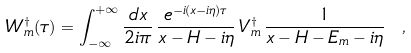Convert formula to latex. <formula><loc_0><loc_0><loc_500><loc_500>W _ { m } ^ { \dag } ( \tau ) = \int _ { - \infty } ^ { + \infty } \frac { d x } { 2 i \pi } \, \frac { e ^ { - i ( x - i \eta ) \tau } } { x - H - i \eta } \, V _ { m } ^ { \dag } \, \frac { 1 } { x - H - E _ { m } - i \eta } \ ,</formula> 